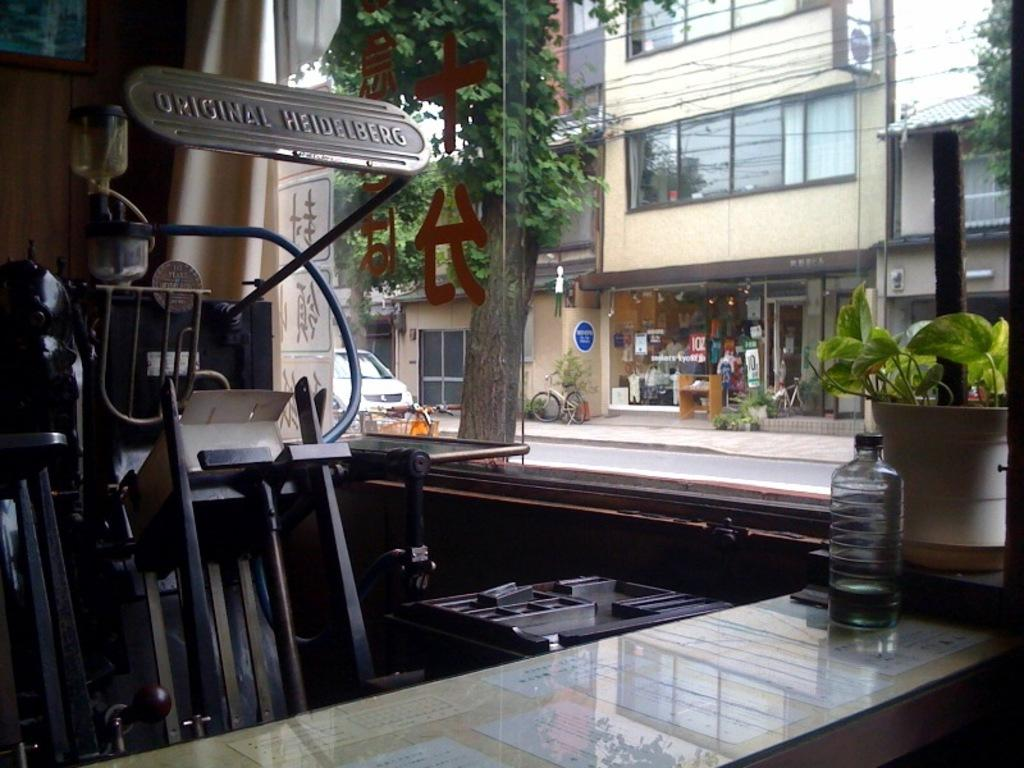<image>
Give a short and clear explanation of the subsequent image. Store front with a waterbottle and the sign "Original Heidelberg". 